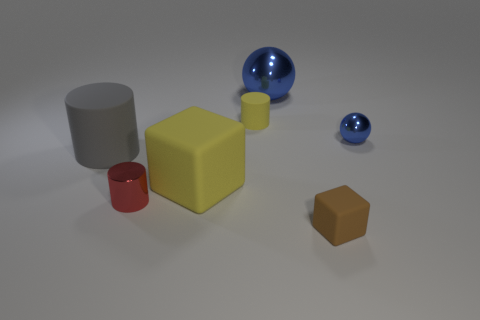What size is the object that is the same color as the big block?
Provide a succinct answer. Small. There is a large object that is the same color as the small rubber cylinder; what is its shape?
Your answer should be compact. Cube. What number of objects are either matte cylinders that are behind the large rubber cylinder or blue things?
Offer a very short reply. 3. Are there fewer small brown metallic cylinders than small rubber things?
Give a very brief answer. Yes. What is the shape of the yellow thing that is made of the same material as the big yellow block?
Offer a very short reply. Cylinder. Are there any small blue shiny things in front of the big gray object?
Provide a succinct answer. No. Are there fewer cylinders to the left of the tiny red cylinder than blocks?
Provide a succinct answer. Yes. What is the tiny blue thing made of?
Your answer should be very brief. Metal. What is the color of the large matte cylinder?
Ensure brevity in your answer.  Gray. What is the color of the matte thing that is behind the red shiny thing and in front of the large gray matte object?
Make the answer very short. Yellow. 